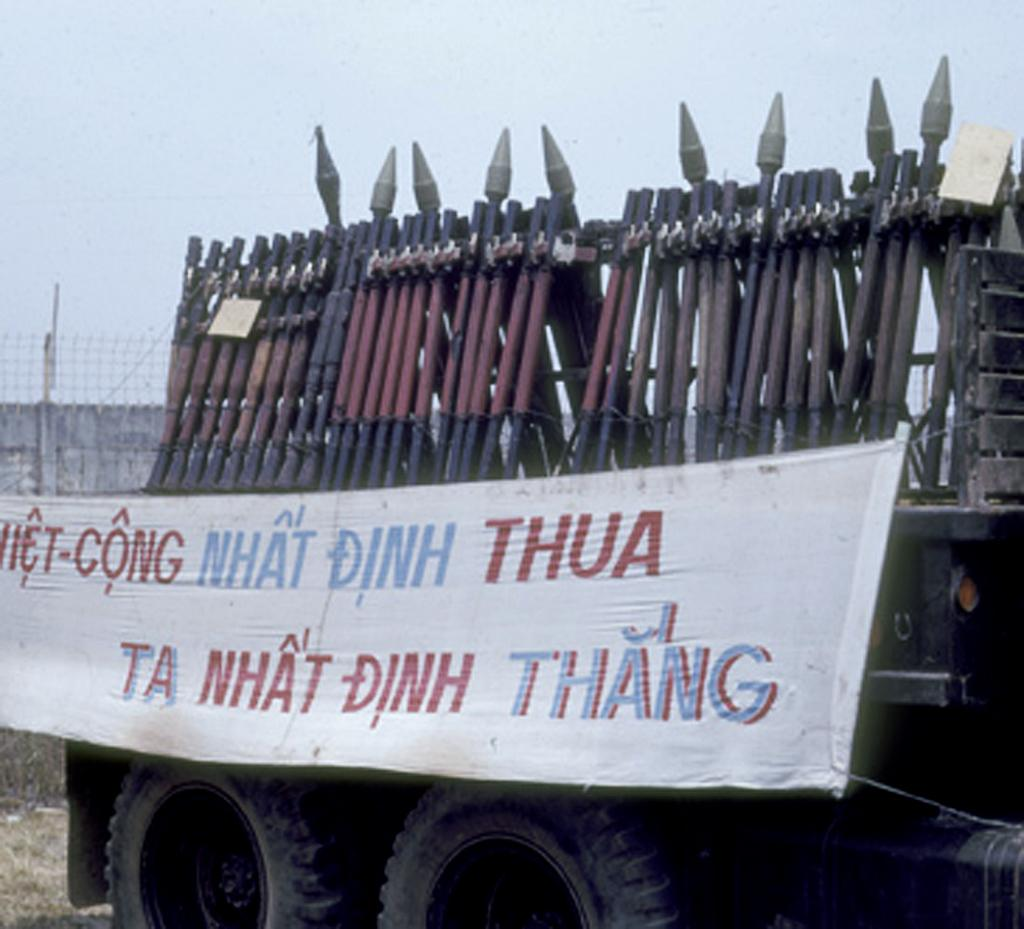What can be seen in the image that resembles a series of vertical structures? There is a group of poles in the image. What is written on the vehicle in the image? There is a banner with text on a vehicle. What type of barrier is visible in the background of the image? There is a fence in the background of the image. What part of the natural environment is visible in the image? The sky is visible in the background of the image. What type of wine is being served at the event in the image? There is no event or wine present in the image; it features a group of poles, a vehicle with a banner, a fence, and the sky. How does the acoustics of the area affect the sound quality in the image? There is no information about the acoustics or sound quality in the image, as it only shows a group of poles, a vehicle with a banner, a fence, and the sky. 